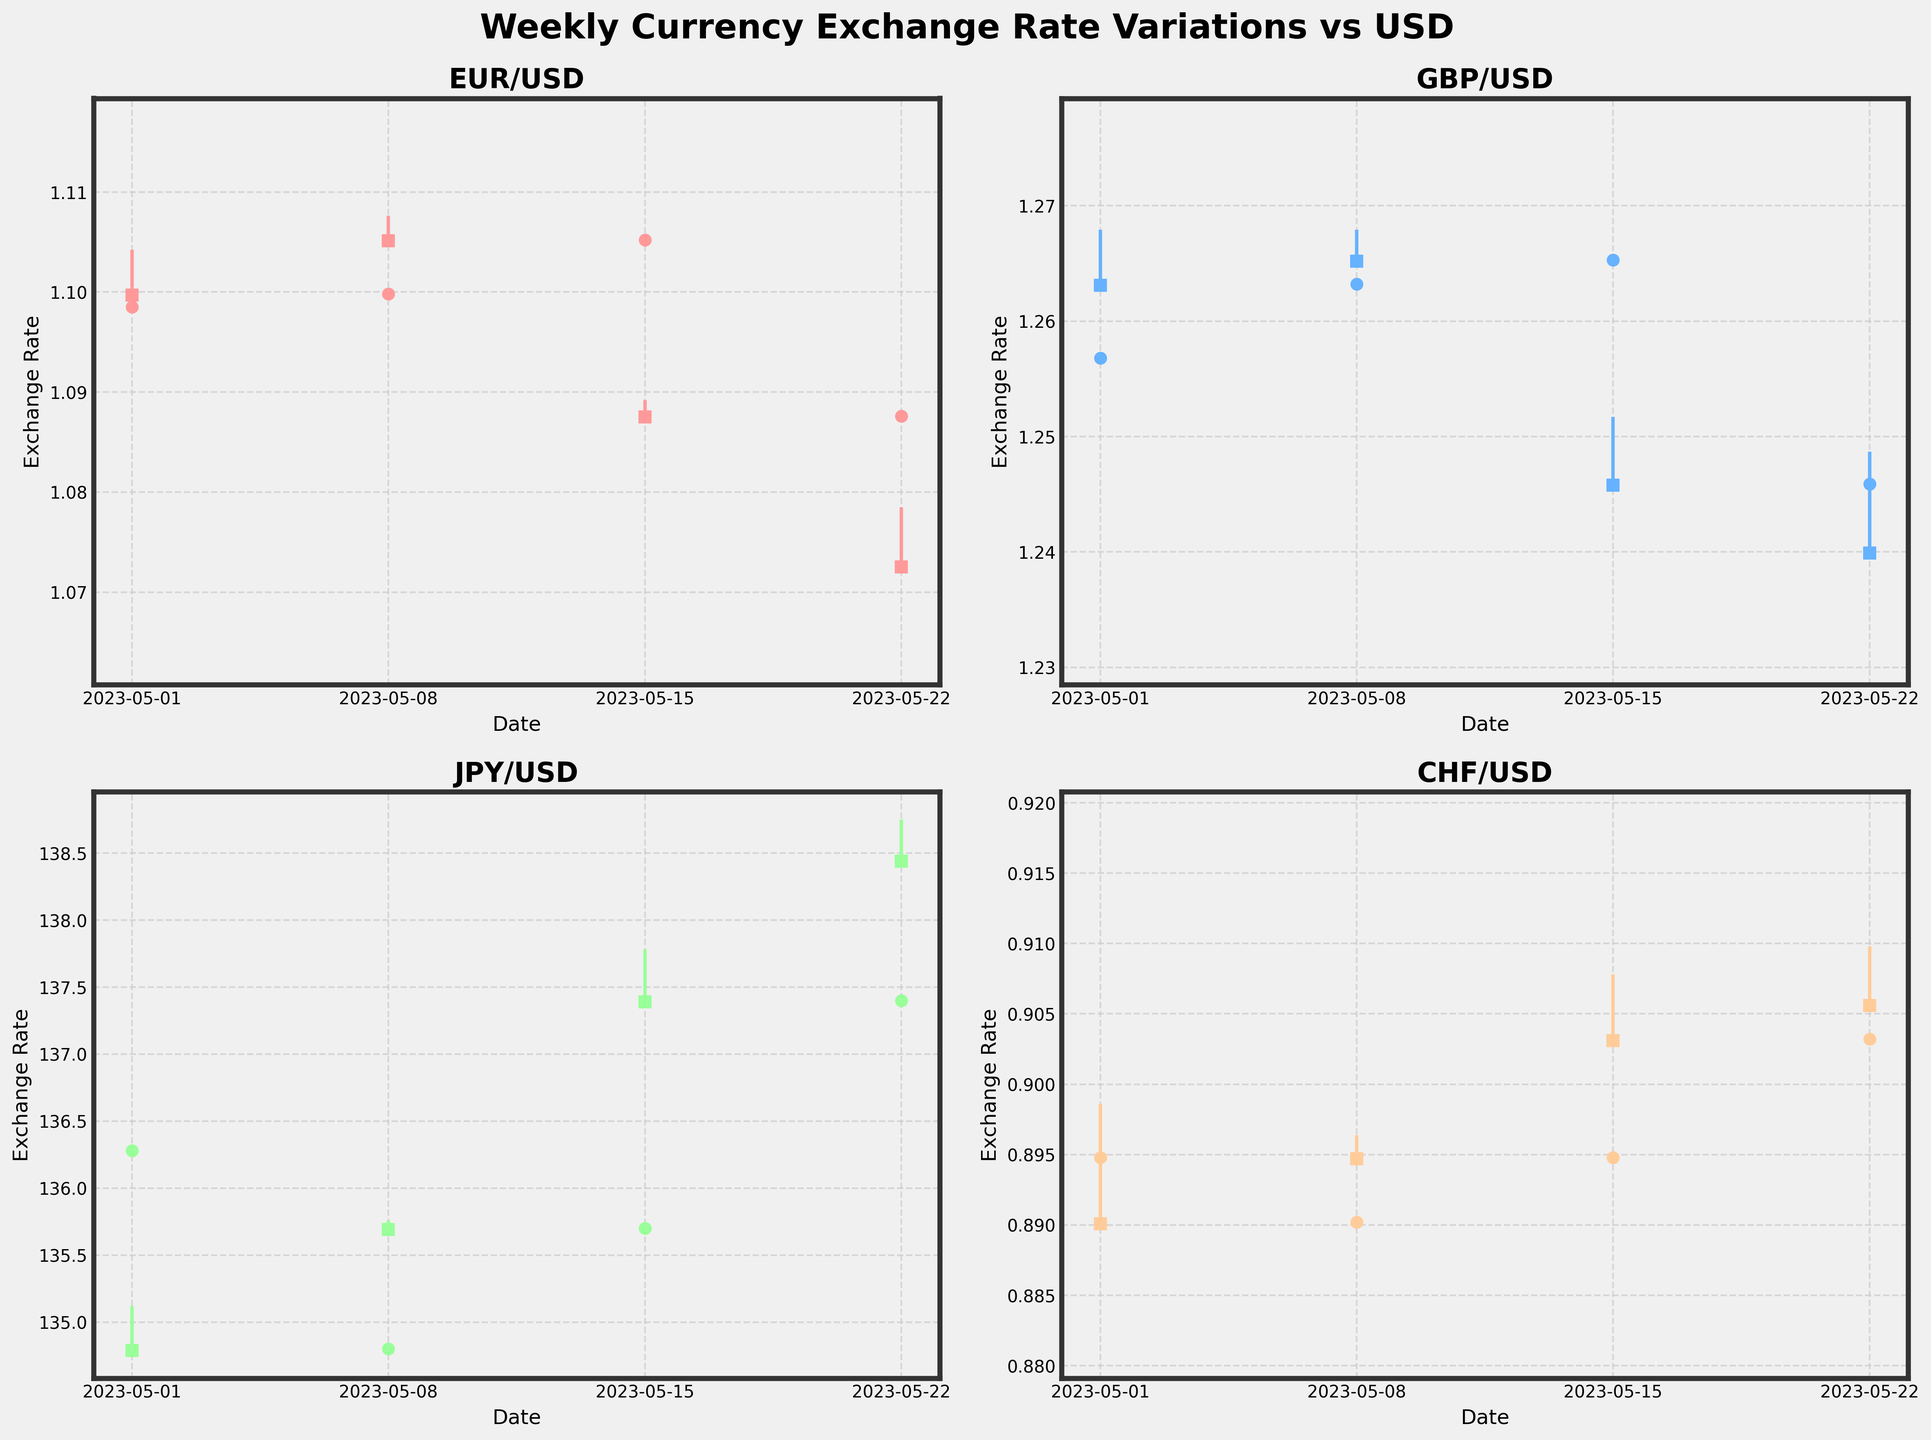What is the title of the figure? The title of the figure is prominently positioned at the top-center of the plot, showing the overall subject of the figure.
Answer: Weekly Currency Exchange Rate Variations vs USD How many major currencies are visualized in the figure? The figure has subplots, each representing a different major currency against USD. Counting the titles of the subplots indicates the number of currencies visualized.
Answer: Four Which currency had the highest closing rate in any week during May 2023? To determine which currency had the highest closing rate, we need to check the highest point of the closing rates across all weeks and all subplots.
Answer: JPY on 2023-05-22, at 138.44 What was the closing rate of CHF on 2023-05-22? To find the closing rate of CHF on 2023-05-22, locate the subplot for CHF and check the closing point on that specific date.
Answer: 0.9056 What is the average opening rate of the GBP for May 2023? Collect the opening rates of GBP for each week in May, sum them up, and divide by the number of weeks (1.2568 + 1.2632 + 1.2653 + 1.2459) / 4. Average = 1.2578
Answer: 1.2578 Which currency experienced the largest drop from its weekly high to its weekly low during May 2023? Identify the highest weekly high and lowest weekly low for each currency, then calculate the drop (high - low) and find which one is the largest.
Answer: EUR on 2023-05-22 with a drop of 0.0383 (1.1076 - 1.0694) Did any currency's closing rate remain the same for two consecutive weeks? Check each subplot's closing points to see if they are identical for two consecutive weeks.
Answer: No How does the closing rate of EUR on 2023-05-15 compare to the closing rate of USD on 2023-05-08? Locate the subplot for EUR, find the closing rate on 2023-05-15, and compare it to the closing rate of EUR on 2023-05-08.
Answer: The closing rate on 2023-05-15 (1.0875 EUR/USD) is lower than on 2023-05-08 (1.1051 EUR/USD) On which date did JPY have the lowest opening rate, and what was the rate? Check the opening rates for JPY on the dates in May, and identify the date with the lowest rate and the corresponding value.
Answer: 2023-05-22 at 137.24 What is the maximum weekly range (high minus low) for GBP in May 2023, and which week did it occur? Calculate the weekly range by subtracting each week's low from its high for GBP and determine the maximum range and corresponding week.
Answer: Week of 2023-05-01, with a range of 0.0180 (1.2679 - 1.2499) 